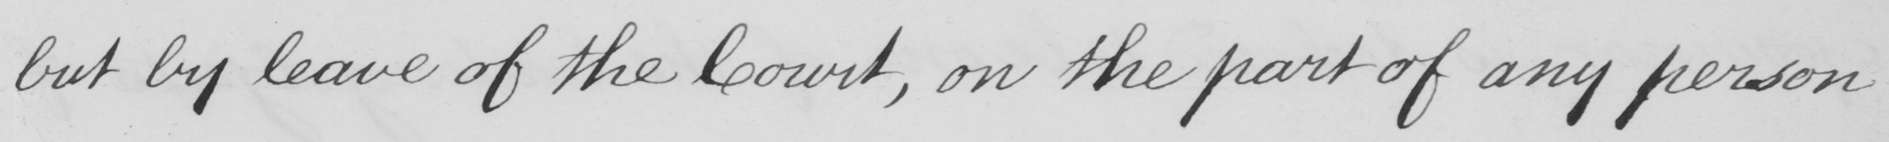Can you tell me what this handwritten text says? but by leave of the Court , on the part of any person 